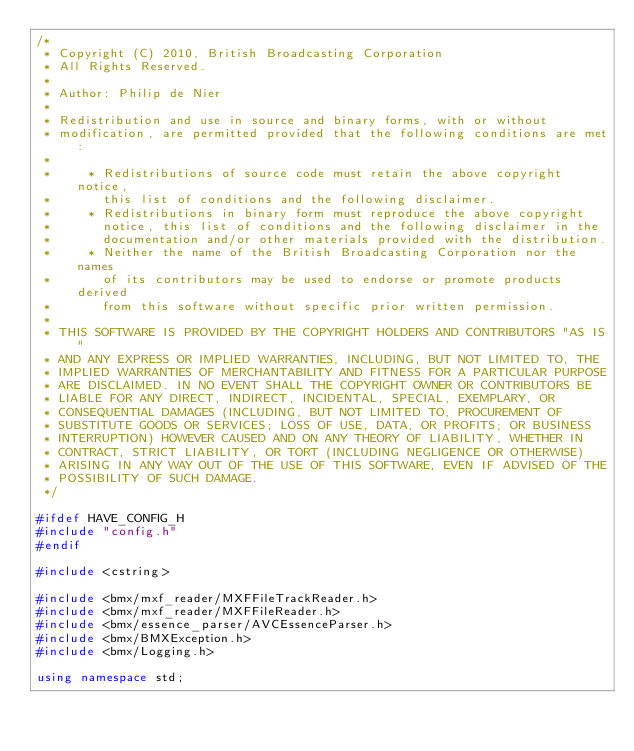Convert code to text. <code><loc_0><loc_0><loc_500><loc_500><_C++_>/*
 * Copyright (C) 2010, British Broadcasting Corporation
 * All Rights Reserved.
 *
 * Author: Philip de Nier
 *
 * Redistribution and use in source and binary forms, with or without
 * modification, are permitted provided that the following conditions are met:
 *
 *     * Redistributions of source code must retain the above copyright notice,
 *       this list of conditions and the following disclaimer.
 *     * Redistributions in binary form must reproduce the above copyright
 *       notice, this list of conditions and the following disclaimer in the
 *       documentation and/or other materials provided with the distribution.
 *     * Neither the name of the British Broadcasting Corporation nor the names
 *       of its contributors may be used to endorse or promote products derived
 *       from this software without specific prior written permission.
 *
 * THIS SOFTWARE IS PROVIDED BY THE COPYRIGHT HOLDERS AND CONTRIBUTORS "AS IS"
 * AND ANY EXPRESS OR IMPLIED WARRANTIES, INCLUDING, BUT NOT LIMITED TO, THE
 * IMPLIED WARRANTIES OF MERCHANTABILITY AND FITNESS FOR A PARTICULAR PURPOSE
 * ARE DISCLAIMED. IN NO EVENT SHALL THE COPYRIGHT OWNER OR CONTRIBUTORS BE
 * LIABLE FOR ANY DIRECT, INDIRECT, INCIDENTAL, SPECIAL, EXEMPLARY, OR
 * CONSEQUENTIAL DAMAGES (INCLUDING, BUT NOT LIMITED TO, PROCUREMENT OF
 * SUBSTITUTE GOODS OR SERVICES; LOSS OF USE, DATA, OR PROFITS; OR BUSINESS
 * INTERRUPTION) HOWEVER CAUSED AND ON ANY THEORY OF LIABILITY, WHETHER IN
 * CONTRACT, STRICT LIABILITY, OR TORT (INCLUDING NEGLIGENCE OR OTHERWISE)
 * ARISING IN ANY WAY OUT OF THE USE OF THIS SOFTWARE, EVEN IF ADVISED OF THE
 * POSSIBILITY OF SUCH DAMAGE.
 */

#ifdef HAVE_CONFIG_H
#include "config.h"
#endif

#include <cstring>

#include <bmx/mxf_reader/MXFFileTrackReader.h>
#include <bmx/mxf_reader/MXFFileReader.h>
#include <bmx/essence_parser/AVCEssenceParser.h>
#include <bmx/BMXException.h>
#include <bmx/Logging.h>

using namespace std;</code> 